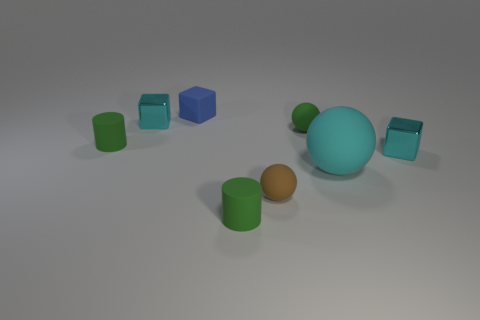What color is the tiny metal block that is to the left of the blue matte cube?
Your answer should be very brief. Cyan. There is a tiny block that is in front of the green matte cylinder behind the large cyan thing; what number of matte cylinders are to the right of it?
Keep it short and to the point. 0. There is a small green object on the left side of the blue block; what number of big cyan things are behind it?
Keep it short and to the point. 0. There is a large rubber object; how many brown things are to the right of it?
Provide a succinct answer. 0. What number of other objects are there of the same size as the blue thing?
Provide a short and direct response. 6. The other green thing that is the same shape as the big rubber thing is what size?
Provide a succinct answer. Small. There is a small green thing in front of the large cyan rubber object; what shape is it?
Keep it short and to the point. Cylinder. What is the color of the cylinder that is behind the small cyan metallic block that is to the right of the blue rubber block?
Provide a short and direct response. Green. How many things are cyan objects that are on the right side of the small brown rubber ball or brown rubber balls?
Give a very brief answer. 3. Does the brown object have the same size as the block in front of the small green sphere?
Provide a short and direct response. Yes. 